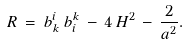Convert formula to latex. <formula><loc_0><loc_0><loc_500><loc_500>R \, = \, b _ { k } ^ { i } \, b _ { i } ^ { k } \, - \, 4 \, H ^ { 2 } \, - \, \frac { 2 } { a ^ { 2 } } .</formula> 